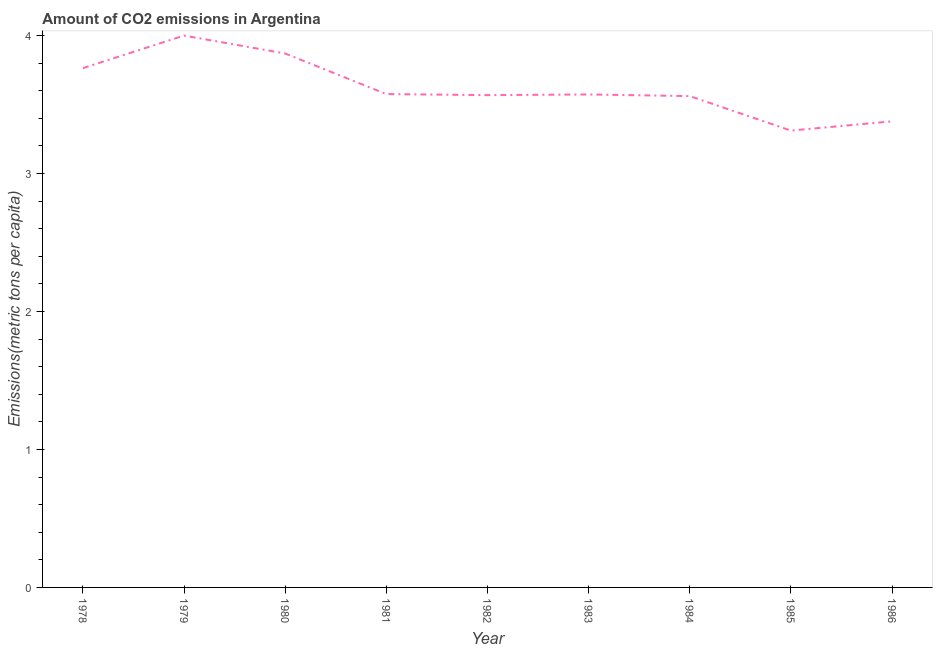What is the amount of co2 emissions in 1982?
Offer a terse response. 3.57. Across all years, what is the maximum amount of co2 emissions?
Offer a terse response. 4. Across all years, what is the minimum amount of co2 emissions?
Your answer should be very brief. 3.31. In which year was the amount of co2 emissions maximum?
Offer a very short reply. 1979. In which year was the amount of co2 emissions minimum?
Offer a terse response. 1985. What is the sum of the amount of co2 emissions?
Your response must be concise. 32.59. What is the difference between the amount of co2 emissions in 1982 and 1986?
Your answer should be compact. 0.19. What is the average amount of co2 emissions per year?
Offer a terse response. 3.62. What is the median amount of co2 emissions?
Your answer should be compact. 3.57. Do a majority of the years between 1984 and 1978 (inclusive) have amount of co2 emissions greater than 0.4 metric tons per capita?
Give a very brief answer. Yes. What is the ratio of the amount of co2 emissions in 1979 to that in 1985?
Offer a terse response. 1.21. What is the difference between the highest and the second highest amount of co2 emissions?
Provide a succinct answer. 0.13. What is the difference between the highest and the lowest amount of co2 emissions?
Keep it short and to the point. 0.69. In how many years, is the amount of co2 emissions greater than the average amount of co2 emissions taken over all years?
Provide a short and direct response. 3. Does the amount of co2 emissions monotonically increase over the years?
Ensure brevity in your answer.  No. How many years are there in the graph?
Your response must be concise. 9. What is the difference between two consecutive major ticks on the Y-axis?
Your answer should be very brief. 1. Are the values on the major ticks of Y-axis written in scientific E-notation?
Your answer should be very brief. No. Does the graph contain grids?
Your response must be concise. No. What is the title of the graph?
Give a very brief answer. Amount of CO2 emissions in Argentina. What is the label or title of the Y-axis?
Make the answer very short. Emissions(metric tons per capita). What is the Emissions(metric tons per capita) in 1978?
Your answer should be compact. 3.76. What is the Emissions(metric tons per capita) in 1979?
Keep it short and to the point. 4. What is the Emissions(metric tons per capita) in 1980?
Provide a short and direct response. 3.87. What is the Emissions(metric tons per capita) in 1981?
Provide a short and direct response. 3.57. What is the Emissions(metric tons per capita) in 1982?
Provide a short and direct response. 3.57. What is the Emissions(metric tons per capita) of 1983?
Ensure brevity in your answer.  3.57. What is the Emissions(metric tons per capita) in 1984?
Your answer should be compact. 3.56. What is the Emissions(metric tons per capita) in 1985?
Keep it short and to the point. 3.31. What is the Emissions(metric tons per capita) of 1986?
Provide a short and direct response. 3.38. What is the difference between the Emissions(metric tons per capita) in 1978 and 1979?
Offer a very short reply. -0.24. What is the difference between the Emissions(metric tons per capita) in 1978 and 1980?
Your answer should be very brief. -0.11. What is the difference between the Emissions(metric tons per capita) in 1978 and 1981?
Offer a very short reply. 0.19. What is the difference between the Emissions(metric tons per capita) in 1978 and 1982?
Make the answer very short. 0.2. What is the difference between the Emissions(metric tons per capita) in 1978 and 1983?
Offer a terse response. 0.19. What is the difference between the Emissions(metric tons per capita) in 1978 and 1984?
Your answer should be compact. 0.2. What is the difference between the Emissions(metric tons per capita) in 1978 and 1985?
Your response must be concise. 0.45. What is the difference between the Emissions(metric tons per capita) in 1978 and 1986?
Offer a terse response. 0.39. What is the difference between the Emissions(metric tons per capita) in 1979 and 1980?
Your answer should be very brief. 0.13. What is the difference between the Emissions(metric tons per capita) in 1979 and 1981?
Make the answer very short. 0.42. What is the difference between the Emissions(metric tons per capita) in 1979 and 1982?
Provide a succinct answer. 0.43. What is the difference between the Emissions(metric tons per capita) in 1979 and 1983?
Your response must be concise. 0.43. What is the difference between the Emissions(metric tons per capita) in 1979 and 1984?
Your answer should be compact. 0.44. What is the difference between the Emissions(metric tons per capita) in 1979 and 1985?
Offer a terse response. 0.69. What is the difference between the Emissions(metric tons per capita) in 1979 and 1986?
Offer a very short reply. 0.62. What is the difference between the Emissions(metric tons per capita) in 1980 and 1981?
Offer a terse response. 0.29. What is the difference between the Emissions(metric tons per capita) in 1980 and 1982?
Make the answer very short. 0.3. What is the difference between the Emissions(metric tons per capita) in 1980 and 1983?
Keep it short and to the point. 0.3. What is the difference between the Emissions(metric tons per capita) in 1980 and 1984?
Make the answer very short. 0.31. What is the difference between the Emissions(metric tons per capita) in 1980 and 1985?
Offer a very short reply. 0.56. What is the difference between the Emissions(metric tons per capita) in 1980 and 1986?
Your answer should be compact. 0.49. What is the difference between the Emissions(metric tons per capita) in 1981 and 1982?
Your response must be concise. 0.01. What is the difference between the Emissions(metric tons per capita) in 1981 and 1983?
Offer a very short reply. 0. What is the difference between the Emissions(metric tons per capita) in 1981 and 1984?
Provide a short and direct response. 0.01. What is the difference between the Emissions(metric tons per capita) in 1981 and 1985?
Provide a succinct answer. 0.26. What is the difference between the Emissions(metric tons per capita) in 1981 and 1986?
Make the answer very short. 0.2. What is the difference between the Emissions(metric tons per capita) in 1982 and 1983?
Provide a succinct answer. -0. What is the difference between the Emissions(metric tons per capita) in 1982 and 1984?
Ensure brevity in your answer.  0.01. What is the difference between the Emissions(metric tons per capita) in 1982 and 1985?
Ensure brevity in your answer.  0.26. What is the difference between the Emissions(metric tons per capita) in 1982 and 1986?
Ensure brevity in your answer.  0.19. What is the difference between the Emissions(metric tons per capita) in 1983 and 1984?
Your answer should be very brief. 0.01. What is the difference between the Emissions(metric tons per capita) in 1983 and 1985?
Your response must be concise. 0.26. What is the difference between the Emissions(metric tons per capita) in 1983 and 1986?
Provide a short and direct response. 0.19. What is the difference between the Emissions(metric tons per capita) in 1984 and 1985?
Make the answer very short. 0.25. What is the difference between the Emissions(metric tons per capita) in 1984 and 1986?
Offer a very short reply. 0.18. What is the difference between the Emissions(metric tons per capita) in 1985 and 1986?
Offer a terse response. -0.07. What is the ratio of the Emissions(metric tons per capita) in 1978 to that in 1979?
Offer a very short reply. 0.94. What is the ratio of the Emissions(metric tons per capita) in 1978 to that in 1980?
Your answer should be compact. 0.97. What is the ratio of the Emissions(metric tons per capita) in 1978 to that in 1981?
Your answer should be compact. 1.05. What is the ratio of the Emissions(metric tons per capita) in 1978 to that in 1982?
Provide a short and direct response. 1.05. What is the ratio of the Emissions(metric tons per capita) in 1978 to that in 1983?
Your answer should be very brief. 1.05. What is the ratio of the Emissions(metric tons per capita) in 1978 to that in 1984?
Provide a succinct answer. 1.06. What is the ratio of the Emissions(metric tons per capita) in 1978 to that in 1985?
Offer a very short reply. 1.14. What is the ratio of the Emissions(metric tons per capita) in 1978 to that in 1986?
Give a very brief answer. 1.11. What is the ratio of the Emissions(metric tons per capita) in 1979 to that in 1980?
Ensure brevity in your answer.  1.03. What is the ratio of the Emissions(metric tons per capita) in 1979 to that in 1981?
Your answer should be very brief. 1.12. What is the ratio of the Emissions(metric tons per capita) in 1979 to that in 1982?
Your answer should be compact. 1.12. What is the ratio of the Emissions(metric tons per capita) in 1979 to that in 1983?
Keep it short and to the point. 1.12. What is the ratio of the Emissions(metric tons per capita) in 1979 to that in 1984?
Give a very brief answer. 1.12. What is the ratio of the Emissions(metric tons per capita) in 1979 to that in 1985?
Make the answer very short. 1.21. What is the ratio of the Emissions(metric tons per capita) in 1979 to that in 1986?
Make the answer very short. 1.18. What is the ratio of the Emissions(metric tons per capita) in 1980 to that in 1981?
Offer a very short reply. 1.08. What is the ratio of the Emissions(metric tons per capita) in 1980 to that in 1982?
Offer a terse response. 1.08. What is the ratio of the Emissions(metric tons per capita) in 1980 to that in 1983?
Provide a succinct answer. 1.08. What is the ratio of the Emissions(metric tons per capita) in 1980 to that in 1984?
Your answer should be very brief. 1.09. What is the ratio of the Emissions(metric tons per capita) in 1980 to that in 1985?
Offer a terse response. 1.17. What is the ratio of the Emissions(metric tons per capita) in 1980 to that in 1986?
Give a very brief answer. 1.15. What is the ratio of the Emissions(metric tons per capita) in 1981 to that in 1982?
Give a very brief answer. 1. What is the ratio of the Emissions(metric tons per capita) in 1981 to that in 1984?
Your response must be concise. 1. What is the ratio of the Emissions(metric tons per capita) in 1981 to that in 1985?
Offer a terse response. 1.08. What is the ratio of the Emissions(metric tons per capita) in 1981 to that in 1986?
Keep it short and to the point. 1.06. What is the ratio of the Emissions(metric tons per capita) in 1982 to that in 1984?
Give a very brief answer. 1. What is the ratio of the Emissions(metric tons per capita) in 1982 to that in 1985?
Keep it short and to the point. 1.08. What is the ratio of the Emissions(metric tons per capita) in 1982 to that in 1986?
Give a very brief answer. 1.06. What is the ratio of the Emissions(metric tons per capita) in 1983 to that in 1984?
Provide a succinct answer. 1. What is the ratio of the Emissions(metric tons per capita) in 1983 to that in 1985?
Your answer should be compact. 1.08. What is the ratio of the Emissions(metric tons per capita) in 1983 to that in 1986?
Your answer should be very brief. 1.06. What is the ratio of the Emissions(metric tons per capita) in 1984 to that in 1985?
Your answer should be very brief. 1.07. What is the ratio of the Emissions(metric tons per capita) in 1984 to that in 1986?
Make the answer very short. 1.05. 